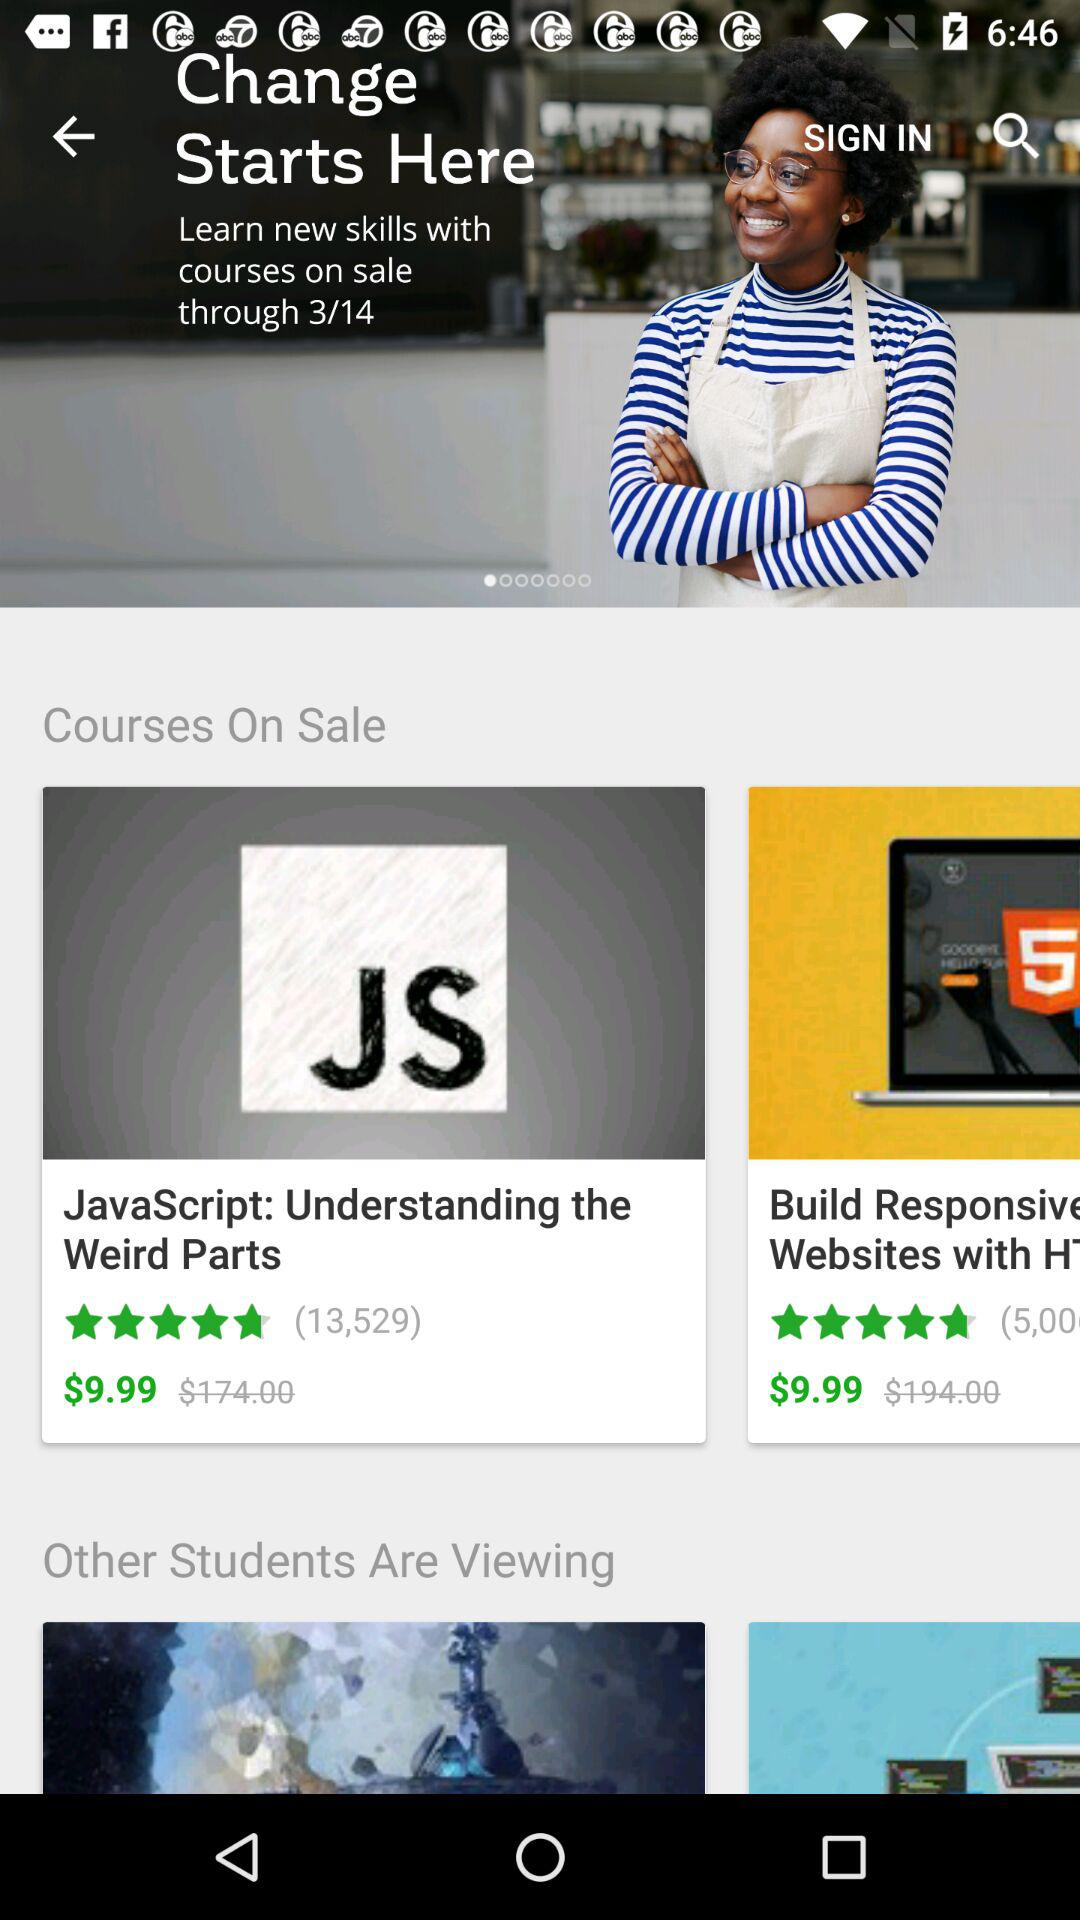How many people have reviewed the "JavaScript" courses? The number of people that have reviewed the "JavaScript" courses is 13,529. 